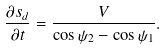Convert formula to latex. <formula><loc_0><loc_0><loc_500><loc_500>\frac { \partial { s _ { d } } } { \partial { t } } = \frac { V } { \cos \psi _ { 2 } - \cos \psi _ { 1 } } .</formula> 